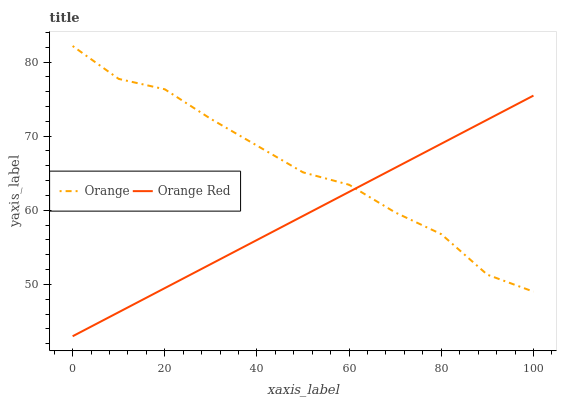Does Orange Red have the minimum area under the curve?
Answer yes or no. Yes. Does Orange have the maximum area under the curve?
Answer yes or no. Yes. Does Orange Red have the maximum area under the curve?
Answer yes or no. No. Is Orange Red the smoothest?
Answer yes or no. Yes. Is Orange the roughest?
Answer yes or no. Yes. Is Orange Red the roughest?
Answer yes or no. No. Does Orange Red have the lowest value?
Answer yes or no. Yes. Does Orange have the highest value?
Answer yes or no. Yes. Does Orange Red have the highest value?
Answer yes or no. No. Does Orange Red intersect Orange?
Answer yes or no. Yes. Is Orange Red less than Orange?
Answer yes or no. No. Is Orange Red greater than Orange?
Answer yes or no. No. 